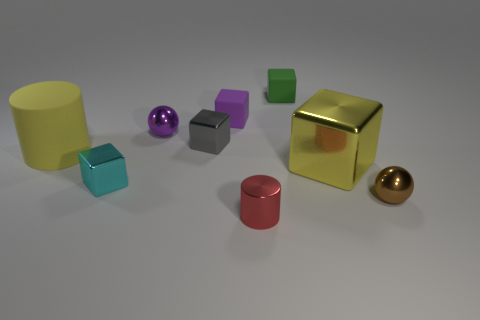Subtract all tiny purple rubber cubes. How many cubes are left? 4 Subtract all green cubes. How many cubes are left? 4 Subtract all red blocks. Subtract all yellow cylinders. How many blocks are left? 5 Subtract all cubes. How many objects are left? 4 Add 7 big blue metallic balls. How many big blue metallic balls exist? 7 Subtract 1 gray cubes. How many objects are left? 8 Subtract all small cyan metal blocks. Subtract all tiny purple cubes. How many objects are left? 7 Add 2 tiny red things. How many tiny red things are left? 3 